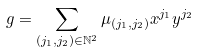Convert formula to latex. <formula><loc_0><loc_0><loc_500><loc_500>g = \sum _ { \left ( j _ { 1 } , j _ { 2 } \right ) \in \mathbb { N } ^ { 2 } } \mu _ { \left ( j _ { 1 } , j _ { 2 } \right ) } x ^ { j _ { 1 } } y ^ { j _ { 2 } }</formula> 